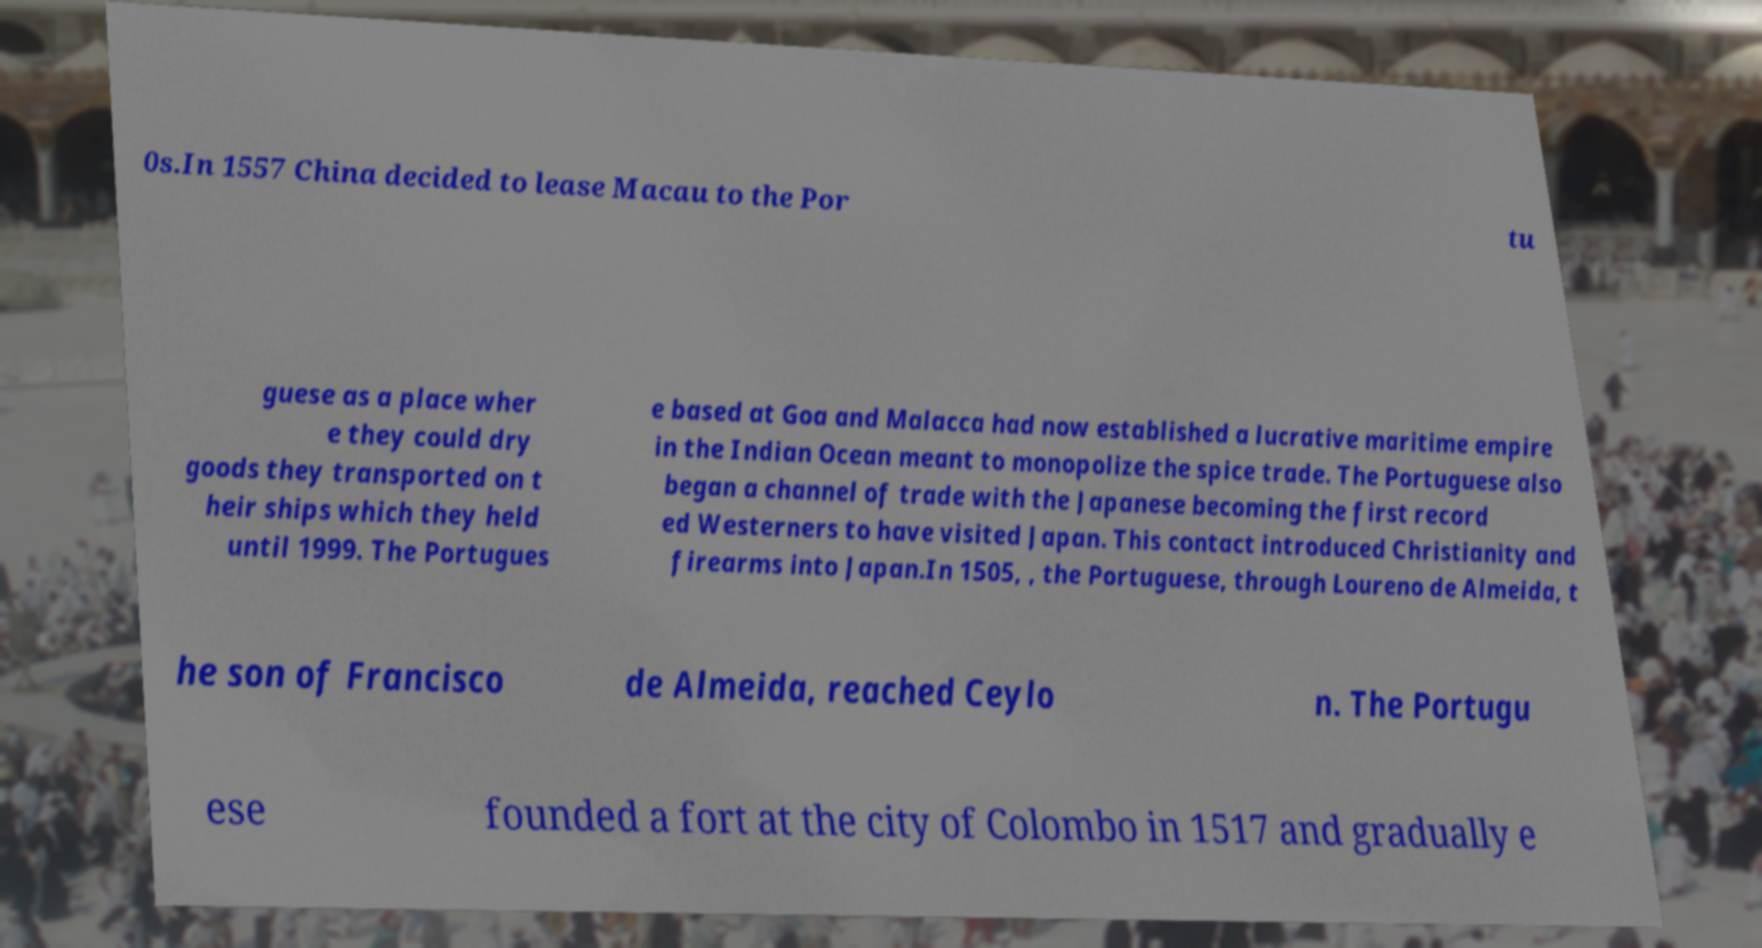What messages or text are displayed in this image? I need them in a readable, typed format. 0s.In 1557 China decided to lease Macau to the Por tu guese as a place wher e they could dry goods they transported on t heir ships which they held until 1999. The Portugues e based at Goa and Malacca had now established a lucrative maritime empire in the Indian Ocean meant to monopolize the spice trade. The Portuguese also began a channel of trade with the Japanese becoming the first record ed Westerners to have visited Japan. This contact introduced Christianity and firearms into Japan.In 1505, , the Portuguese, through Loureno de Almeida, t he son of Francisco de Almeida, reached Ceylo n. The Portugu ese founded a fort at the city of Colombo in 1517 and gradually e 